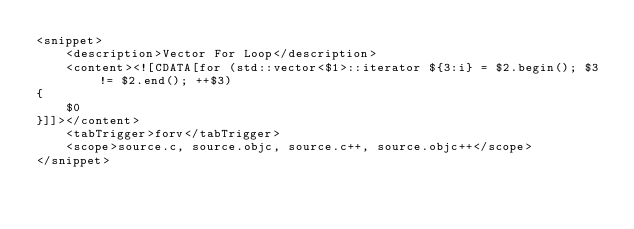Convert code to text. <code><loc_0><loc_0><loc_500><loc_500><_XML_><snippet>
	<description>Vector For Loop</description>
	<content><![CDATA[for (std::vector<$1>::iterator ${3:i} = $2.begin(); $3 != $2.end(); ++$3)
{
	$0
}]]></content>
	<tabTrigger>forv</tabTrigger>
	<scope>source.c, source.objc, source.c++, source.objc++</scope>
</snippet>
</code> 